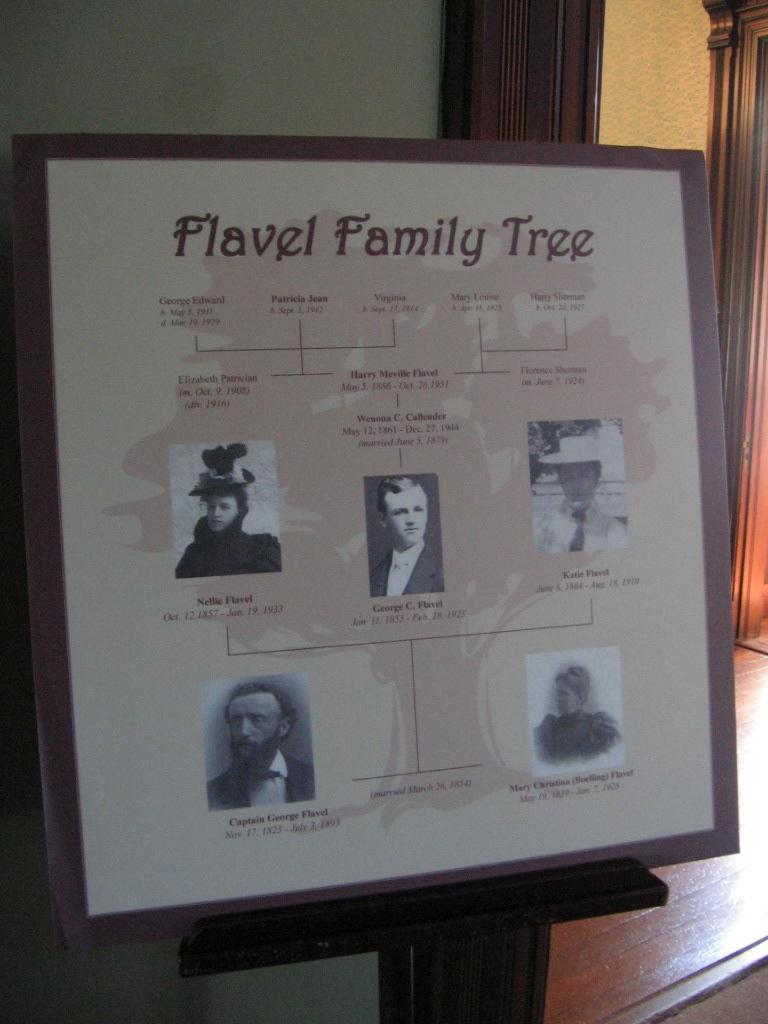What is the main object in the middle of the image? There is a banner in the middle of the image. What is behind the banner? There is a wall behind the banner. How many girls are sitting at the desk in the image? There are no girls or desks present in the image; it only features a banner and a wall. 